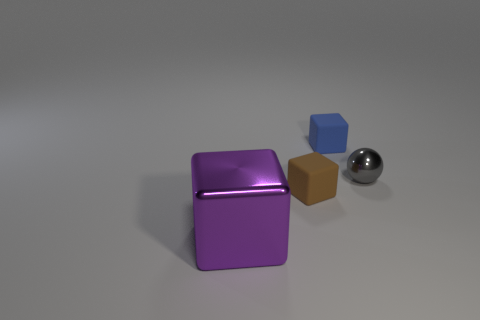Subtract all matte cubes. How many cubes are left? 1 Subtract 1 blocks. How many blocks are left? 2 Subtract all blocks. How many objects are left? 1 Subtract all purple blocks. Subtract all green cylinders. How many blocks are left? 2 Subtract all green cylinders. How many cyan cubes are left? 0 Subtract all tiny cyan balls. Subtract all big purple objects. How many objects are left? 3 Add 1 brown rubber blocks. How many brown rubber blocks are left? 2 Add 3 blocks. How many blocks exist? 6 Add 4 small gray metallic cubes. How many objects exist? 8 Subtract 1 gray balls. How many objects are left? 3 